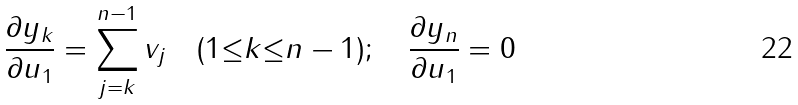Convert formula to latex. <formula><loc_0><loc_0><loc_500><loc_500>\frac { { \partial } y _ { k } } { { \partial } u _ { 1 } } = \sum _ { j = k } ^ { n - 1 } v _ { j } \quad ( 1 { \leq } k { \leq } n - 1 ) ; \quad \frac { { \partial } y _ { n } } { { \partial } u _ { 1 } } = 0</formula> 